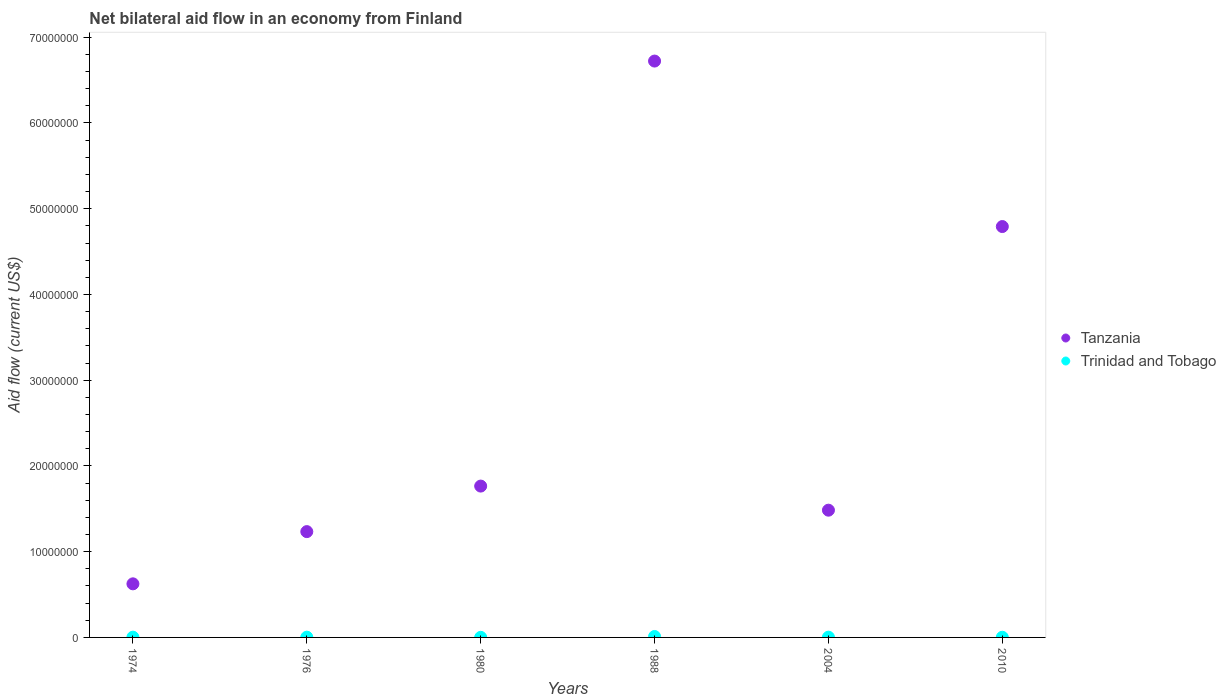What is the net bilateral aid flow in Trinidad and Tobago in 1980?
Your response must be concise. 10000. Across all years, what is the maximum net bilateral aid flow in Tanzania?
Offer a terse response. 6.72e+07. Across all years, what is the minimum net bilateral aid flow in Trinidad and Tobago?
Your answer should be compact. 10000. In which year was the net bilateral aid flow in Tanzania minimum?
Your response must be concise. 1974. What is the total net bilateral aid flow in Tanzania in the graph?
Provide a succinct answer. 1.66e+08. What is the difference between the net bilateral aid flow in Tanzania in 2004 and the net bilateral aid flow in Trinidad and Tobago in 1974?
Your answer should be very brief. 1.48e+07. What is the average net bilateral aid flow in Tanzania per year?
Give a very brief answer. 2.77e+07. In the year 2010, what is the difference between the net bilateral aid flow in Trinidad and Tobago and net bilateral aid flow in Tanzania?
Your response must be concise. -4.79e+07. What is the ratio of the net bilateral aid flow in Trinidad and Tobago in 1976 to that in 2010?
Keep it short and to the point. 1.5. Is the net bilateral aid flow in Trinidad and Tobago in 1974 less than that in 1976?
Offer a very short reply. No. What is the difference between the highest and the lowest net bilateral aid flow in Trinidad and Tobago?
Your response must be concise. 1.00e+05. Is the sum of the net bilateral aid flow in Tanzania in 1980 and 2004 greater than the maximum net bilateral aid flow in Trinidad and Tobago across all years?
Your answer should be compact. Yes. Does the net bilateral aid flow in Trinidad and Tobago monotonically increase over the years?
Ensure brevity in your answer.  No. Is the net bilateral aid flow in Trinidad and Tobago strictly greater than the net bilateral aid flow in Tanzania over the years?
Provide a succinct answer. No. Is the net bilateral aid flow in Trinidad and Tobago strictly less than the net bilateral aid flow in Tanzania over the years?
Ensure brevity in your answer.  Yes. How many dotlines are there?
Make the answer very short. 2. How many years are there in the graph?
Provide a short and direct response. 6. Are the values on the major ticks of Y-axis written in scientific E-notation?
Your response must be concise. No. Where does the legend appear in the graph?
Provide a short and direct response. Center right. How are the legend labels stacked?
Offer a terse response. Vertical. What is the title of the graph?
Provide a succinct answer. Net bilateral aid flow in an economy from Finland. Does "Finland" appear as one of the legend labels in the graph?
Keep it short and to the point. No. What is the label or title of the Y-axis?
Offer a terse response. Aid flow (current US$). What is the Aid flow (current US$) in Tanzania in 1974?
Make the answer very short. 6.25e+06. What is the Aid flow (current US$) in Tanzania in 1976?
Provide a succinct answer. 1.23e+07. What is the Aid flow (current US$) in Tanzania in 1980?
Ensure brevity in your answer.  1.76e+07. What is the Aid flow (current US$) of Trinidad and Tobago in 1980?
Offer a very short reply. 10000. What is the Aid flow (current US$) in Tanzania in 1988?
Make the answer very short. 6.72e+07. What is the Aid flow (current US$) of Tanzania in 2004?
Provide a short and direct response. 1.48e+07. What is the Aid flow (current US$) of Trinidad and Tobago in 2004?
Your response must be concise. 3.00e+04. What is the Aid flow (current US$) of Tanzania in 2010?
Ensure brevity in your answer.  4.79e+07. Across all years, what is the maximum Aid flow (current US$) of Tanzania?
Your answer should be very brief. 6.72e+07. Across all years, what is the minimum Aid flow (current US$) of Tanzania?
Give a very brief answer. 6.25e+06. What is the total Aid flow (current US$) in Tanzania in the graph?
Offer a very short reply. 1.66e+08. What is the total Aid flow (current US$) in Trinidad and Tobago in the graph?
Your response must be concise. 2.30e+05. What is the difference between the Aid flow (current US$) in Tanzania in 1974 and that in 1976?
Keep it short and to the point. -6.09e+06. What is the difference between the Aid flow (current US$) in Trinidad and Tobago in 1974 and that in 1976?
Ensure brevity in your answer.  0. What is the difference between the Aid flow (current US$) of Tanzania in 1974 and that in 1980?
Your answer should be very brief. -1.14e+07. What is the difference between the Aid flow (current US$) in Trinidad and Tobago in 1974 and that in 1980?
Ensure brevity in your answer.  2.00e+04. What is the difference between the Aid flow (current US$) of Tanzania in 1974 and that in 1988?
Offer a terse response. -6.10e+07. What is the difference between the Aid flow (current US$) in Tanzania in 1974 and that in 2004?
Your response must be concise. -8.59e+06. What is the difference between the Aid flow (current US$) of Tanzania in 1974 and that in 2010?
Offer a terse response. -4.17e+07. What is the difference between the Aid flow (current US$) of Tanzania in 1976 and that in 1980?
Offer a terse response. -5.31e+06. What is the difference between the Aid flow (current US$) in Tanzania in 1976 and that in 1988?
Your response must be concise. -5.49e+07. What is the difference between the Aid flow (current US$) in Tanzania in 1976 and that in 2004?
Make the answer very short. -2.50e+06. What is the difference between the Aid flow (current US$) in Tanzania in 1976 and that in 2010?
Provide a short and direct response. -3.56e+07. What is the difference between the Aid flow (current US$) in Trinidad and Tobago in 1976 and that in 2010?
Ensure brevity in your answer.  10000. What is the difference between the Aid flow (current US$) of Tanzania in 1980 and that in 1988?
Offer a very short reply. -4.96e+07. What is the difference between the Aid flow (current US$) of Trinidad and Tobago in 1980 and that in 1988?
Offer a terse response. -1.00e+05. What is the difference between the Aid flow (current US$) in Tanzania in 1980 and that in 2004?
Your response must be concise. 2.81e+06. What is the difference between the Aid flow (current US$) of Trinidad and Tobago in 1980 and that in 2004?
Provide a short and direct response. -2.00e+04. What is the difference between the Aid flow (current US$) in Tanzania in 1980 and that in 2010?
Your answer should be very brief. -3.03e+07. What is the difference between the Aid flow (current US$) of Trinidad and Tobago in 1980 and that in 2010?
Make the answer very short. -10000. What is the difference between the Aid flow (current US$) in Tanzania in 1988 and that in 2004?
Ensure brevity in your answer.  5.24e+07. What is the difference between the Aid flow (current US$) in Tanzania in 1988 and that in 2010?
Keep it short and to the point. 1.93e+07. What is the difference between the Aid flow (current US$) in Trinidad and Tobago in 1988 and that in 2010?
Provide a short and direct response. 9.00e+04. What is the difference between the Aid flow (current US$) in Tanzania in 2004 and that in 2010?
Your answer should be very brief. -3.31e+07. What is the difference between the Aid flow (current US$) of Tanzania in 1974 and the Aid flow (current US$) of Trinidad and Tobago in 1976?
Keep it short and to the point. 6.22e+06. What is the difference between the Aid flow (current US$) in Tanzania in 1974 and the Aid flow (current US$) in Trinidad and Tobago in 1980?
Your answer should be very brief. 6.24e+06. What is the difference between the Aid flow (current US$) in Tanzania in 1974 and the Aid flow (current US$) in Trinidad and Tobago in 1988?
Your answer should be very brief. 6.14e+06. What is the difference between the Aid flow (current US$) in Tanzania in 1974 and the Aid flow (current US$) in Trinidad and Tobago in 2004?
Your answer should be very brief. 6.22e+06. What is the difference between the Aid flow (current US$) in Tanzania in 1974 and the Aid flow (current US$) in Trinidad and Tobago in 2010?
Provide a succinct answer. 6.23e+06. What is the difference between the Aid flow (current US$) in Tanzania in 1976 and the Aid flow (current US$) in Trinidad and Tobago in 1980?
Offer a very short reply. 1.23e+07. What is the difference between the Aid flow (current US$) of Tanzania in 1976 and the Aid flow (current US$) of Trinidad and Tobago in 1988?
Offer a terse response. 1.22e+07. What is the difference between the Aid flow (current US$) of Tanzania in 1976 and the Aid flow (current US$) of Trinidad and Tobago in 2004?
Provide a succinct answer. 1.23e+07. What is the difference between the Aid flow (current US$) in Tanzania in 1976 and the Aid flow (current US$) in Trinidad and Tobago in 2010?
Offer a very short reply. 1.23e+07. What is the difference between the Aid flow (current US$) in Tanzania in 1980 and the Aid flow (current US$) in Trinidad and Tobago in 1988?
Your answer should be very brief. 1.75e+07. What is the difference between the Aid flow (current US$) in Tanzania in 1980 and the Aid flow (current US$) in Trinidad and Tobago in 2004?
Offer a terse response. 1.76e+07. What is the difference between the Aid flow (current US$) in Tanzania in 1980 and the Aid flow (current US$) in Trinidad and Tobago in 2010?
Give a very brief answer. 1.76e+07. What is the difference between the Aid flow (current US$) in Tanzania in 1988 and the Aid flow (current US$) in Trinidad and Tobago in 2004?
Provide a short and direct response. 6.72e+07. What is the difference between the Aid flow (current US$) of Tanzania in 1988 and the Aid flow (current US$) of Trinidad and Tobago in 2010?
Your answer should be very brief. 6.72e+07. What is the difference between the Aid flow (current US$) in Tanzania in 2004 and the Aid flow (current US$) in Trinidad and Tobago in 2010?
Offer a very short reply. 1.48e+07. What is the average Aid flow (current US$) in Tanzania per year?
Offer a very short reply. 2.77e+07. What is the average Aid flow (current US$) in Trinidad and Tobago per year?
Provide a short and direct response. 3.83e+04. In the year 1974, what is the difference between the Aid flow (current US$) of Tanzania and Aid flow (current US$) of Trinidad and Tobago?
Offer a very short reply. 6.22e+06. In the year 1976, what is the difference between the Aid flow (current US$) of Tanzania and Aid flow (current US$) of Trinidad and Tobago?
Ensure brevity in your answer.  1.23e+07. In the year 1980, what is the difference between the Aid flow (current US$) in Tanzania and Aid flow (current US$) in Trinidad and Tobago?
Offer a very short reply. 1.76e+07. In the year 1988, what is the difference between the Aid flow (current US$) in Tanzania and Aid flow (current US$) in Trinidad and Tobago?
Your response must be concise. 6.71e+07. In the year 2004, what is the difference between the Aid flow (current US$) of Tanzania and Aid flow (current US$) of Trinidad and Tobago?
Your answer should be very brief. 1.48e+07. In the year 2010, what is the difference between the Aid flow (current US$) in Tanzania and Aid flow (current US$) in Trinidad and Tobago?
Give a very brief answer. 4.79e+07. What is the ratio of the Aid flow (current US$) of Tanzania in 1974 to that in 1976?
Provide a short and direct response. 0.51. What is the ratio of the Aid flow (current US$) of Tanzania in 1974 to that in 1980?
Offer a very short reply. 0.35. What is the ratio of the Aid flow (current US$) of Trinidad and Tobago in 1974 to that in 1980?
Provide a short and direct response. 3. What is the ratio of the Aid flow (current US$) of Tanzania in 1974 to that in 1988?
Provide a short and direct response. 0.09. What is the ratio of the Aid flow (current US$) in Trinidad and Tobago in 1974 to that in 1988?
Keep it short and to the point. 0.27. What is the ratio of the Aid flow (current US$) in Tanzania in 1974 to that in 2004?
Your answer should be compact. 0.42. What is the ratio of the Aid flow (current US$) of Trinidad and Tobago in 1974 to that in 2004?
Give a very brief answer. 1. What is the ratio of the Aid flow (current US$) of Tanzania in 1974 to that in 2010?
Your answer should be very brief. 0.13. What is the ratio of the Aid flow (current US$) in Trinidad and Tobago in 1974 to that in 2010?
Offer a terse response. 1.5. What is the ratio of the Aid flow (current US$) of Tanzania in 1976 to that in 1980?
Give a very brief answer. 0.7. What is the ratio of the Aid flow (current US$) of Trinidad and Tobago in 1976 to that in 1980?
Ensure brevity in your answer.  3. What is the ratio of the Aid flow (current US$) in Tanzania in 1976 to that in 1988?
Your answer should be very brief. 0.18. What is the ratio of the Aid flow (current US$) in Trinidad and Tobago in 1976 to that in 1988?
Give a very brief answer. 0.27. What is the ratio of the Aid flow (current US$) of Tanzania in 1976 to that in 2004?
Your answer should be compact. 0.83. What is the ratio of the Aid flow (current US$) in Trinidad and Tobago in 1976 to that in 2004?
Offer a terse response. 1. What is the ratio of the Aid flow (current US$) of Tanzania in 1976 to that in 2010?
Ensure brevity in your answer.  0.26. What is the ratio of the Aid flow (current US$) in Trinidad and Tobago in 1976 to that in 2010?
Make the answer very short. 1.5. What is the ratio of the Aid flow (current US$) of Tanzania in 1980 to that in 1988?
Keep it short and to the point. 0.26. What is the ratio of the Aid flow (current US$) of Trinidad and Tobago in 1980 to that in 1988?
Provide a succinct answer. 0.09. What is the ratio of the Aid flow (current US$) of Tanzania in 1980 to that in 2004?
Offer a terse response. 1.19. What is the ratio of the Aid flow (current US$) of Trinidad and Tobago in 1980 to that in 2004?
Ensure brevity in your answer.  0.33. What is the ratio of the Aid flow (current US$) of Tanzania in 1980 to that in 2010?
Provide a succinct answer. 0.37. What is the ratio of the Aid flow (current US$) of Tanzania in 1988 to that in 2004?
Offer a terse response. 4.53. What is the ratio of the Aid flow (current US$) in Trinidad and Tobago in 1988 to that in 2004?
Offer a very short reply. 3.67. What is the ratio of the Aid flow (current US$) of Tanzania in 1988 to that in 2010?
Your response must be concise. 1.4. What is the ratio of the Aid flow (current US$) in Trinidad and Tobago in 1988 to that in 2010?
Make the answer very short. 5.5. What is the ratio of the Aid flow (current US$) of Tanzania in 2004 to that in 2010?
Ensure brevity in your answer.  0.31. What is the difference between the highest and the second highest Aid flow (current US$) in Tanzania?
Provide a succinct answer. 1.93e+07. What is the difference between the highest and the second highest Aid flow (current US$) of Trinidad and Tobago?
Offer a terse response. 8.00e+04. What is the difference between the highest and the lowest Aid flow (current US$) in Tanzania?
Your answer should be compact. 6.10e+07. 